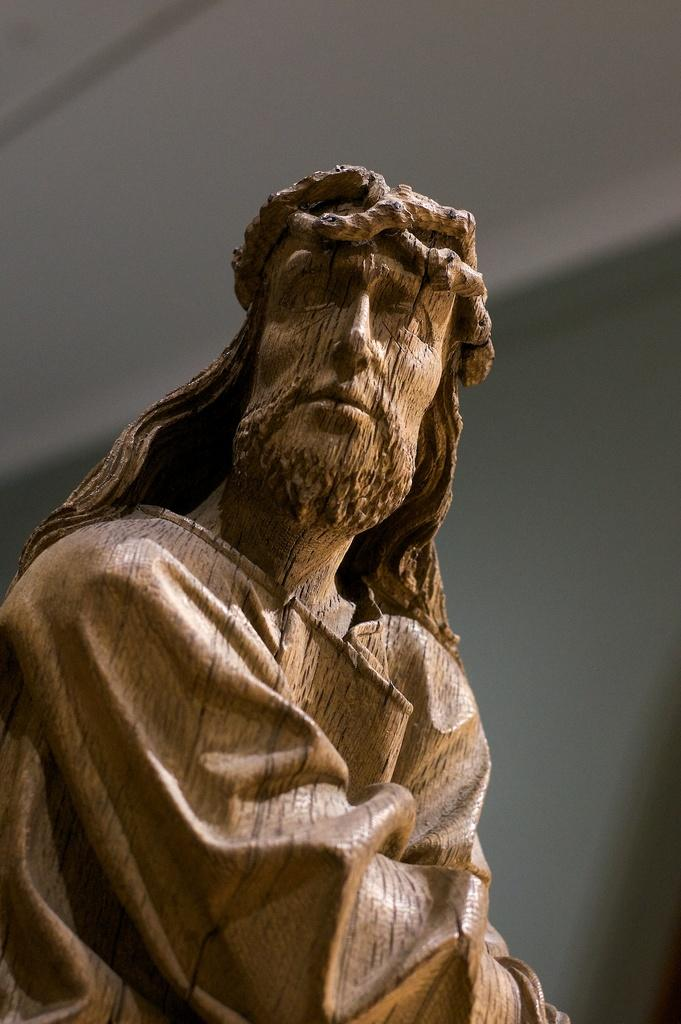What is the main subject in the image? There is a statue in the image. What is the color of the statue? The statue is in brown color. What can be seen in the background of the image? There is a wall in the background of the image. Is the queen sleeping in the crib next to the statue in the image? There is no queen or crib present in the image; it only features a brown statue and a wall in the background. 